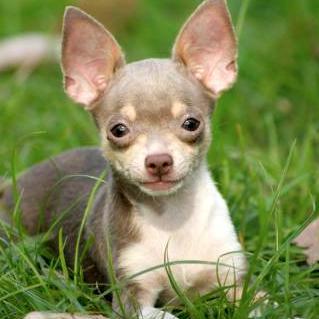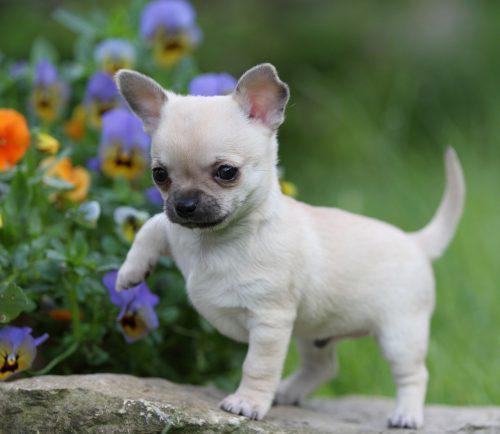The first image is the image on the left, the second image is the image on the right. For the images displayed, is the sentence "All dogs are standing on grass." factually correct? Answer yes or no. No. 